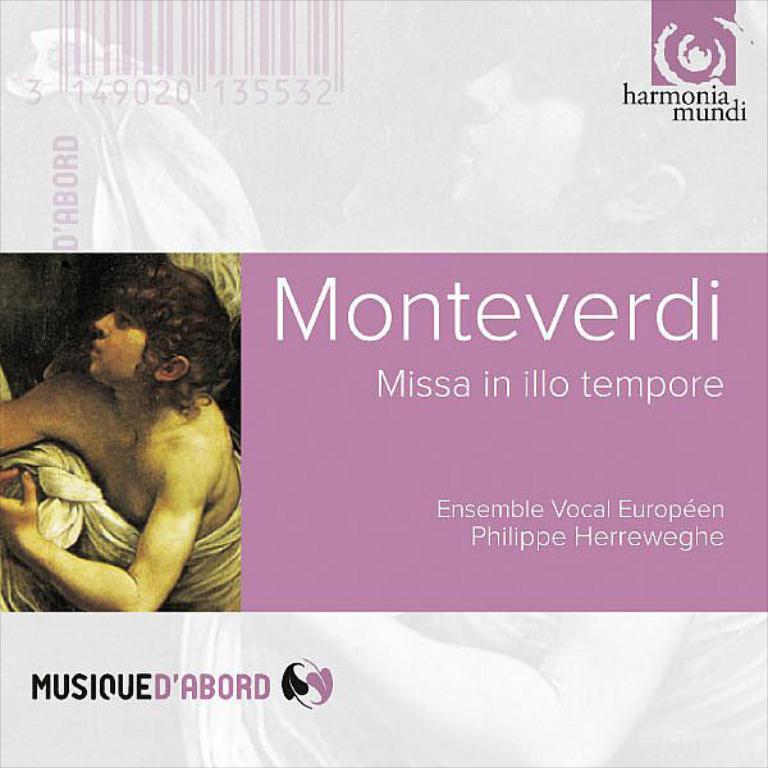Could you give a brief overview of what you see in this image? In the center of the image there is text and there is a photo of a person. 